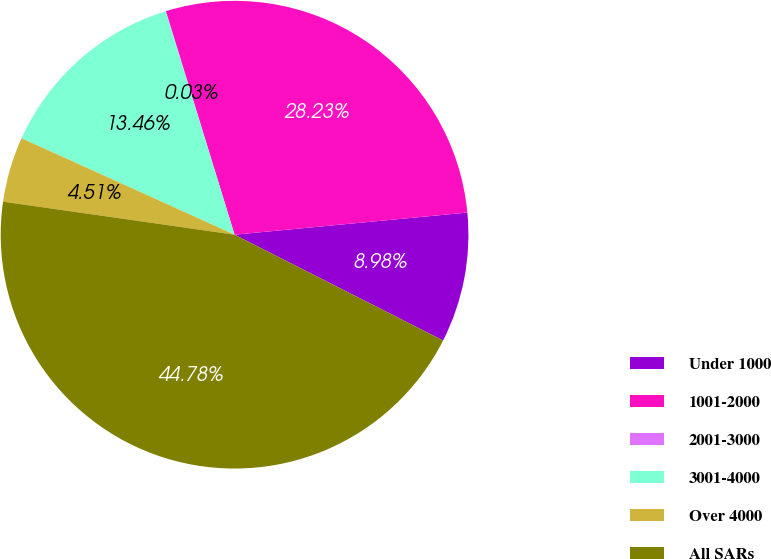Convert chart. <chart><loc_0><loc_0><loc_500><loc_500><pie_chart><fcel>Under 1000<fcel>1001-2000<fcel>2001-3000<fcel>3001-4000<fcel>Over 4000<fcel>All SARs<nl><fcel>8.98%<fcel>28.23%<fcel>0.03%<fcel>13.46%<fcel>4.51%<fcel>44.78%<nl></chart> 